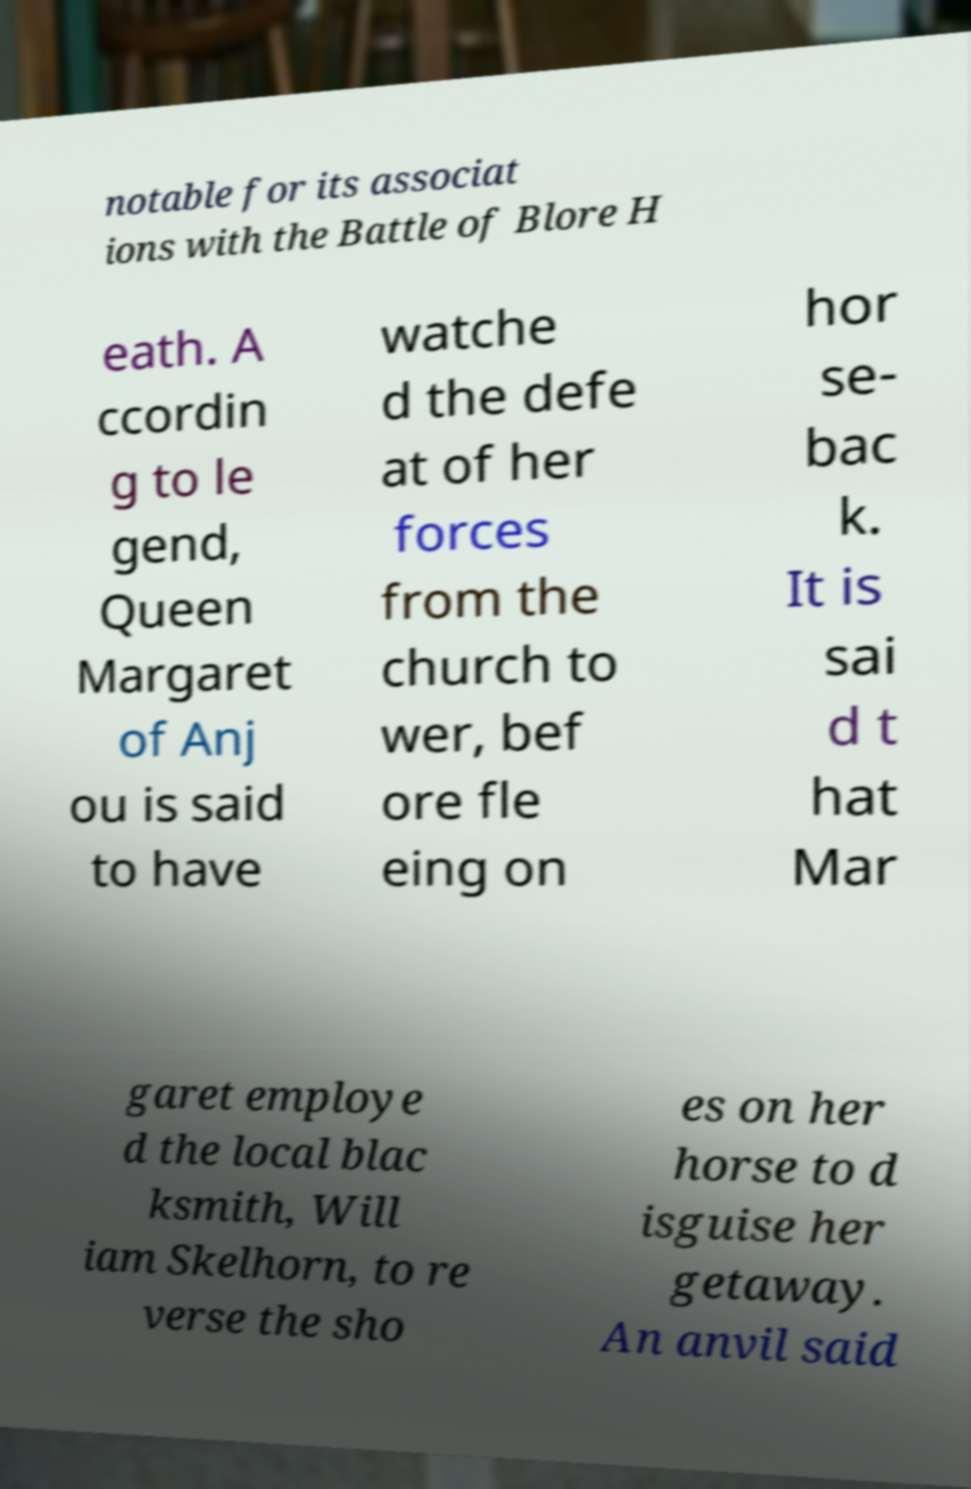I need the written content from this picture converted into text. Can you do that? notable for its associat ions with the Battle of Blore H eath. A ccordin g to le gend, Queen Margaret of Anj ou is said to have watche d the defe at of her forces from the church to wer, bef ore fle eing on hor se- bac k. It is sai d t hat Mar garet employe d the local blac ksmith, Will iam Skelhorn, to re verse the sho es on her horse to d isguise her getaway. An anvil said 